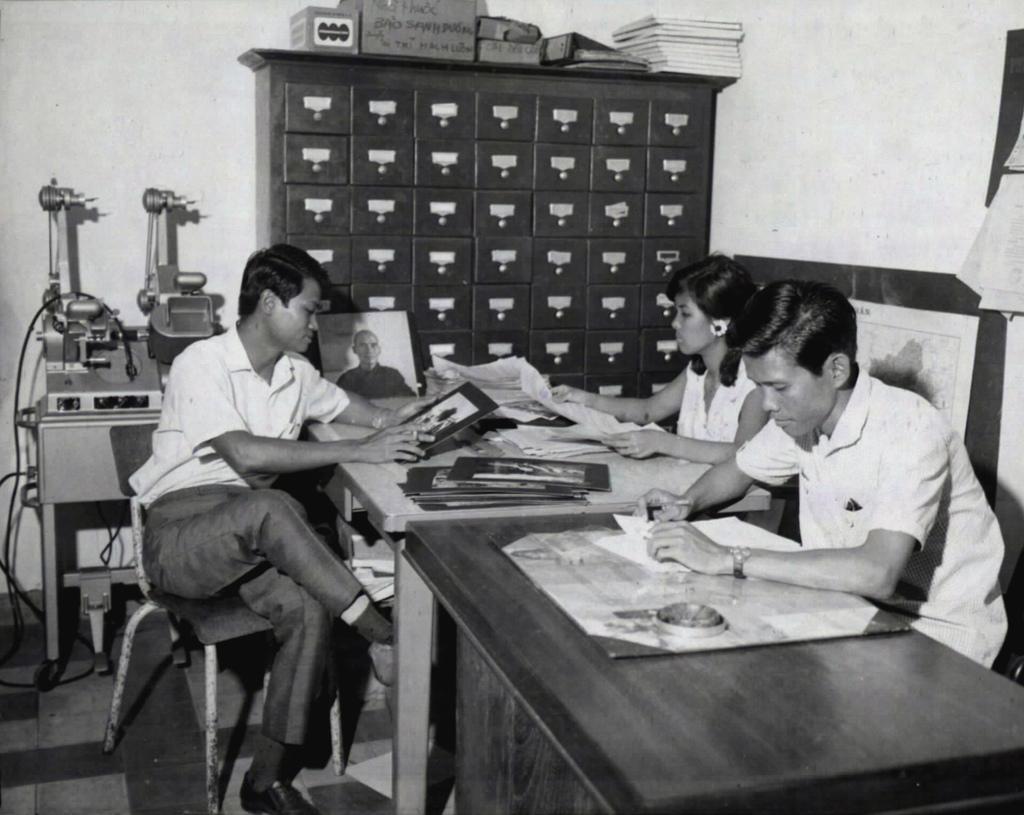Please provide a concise description of this image. There are so many people sitting around a table holding a paper behind them there are lockers and some machines at the corner of the room. 